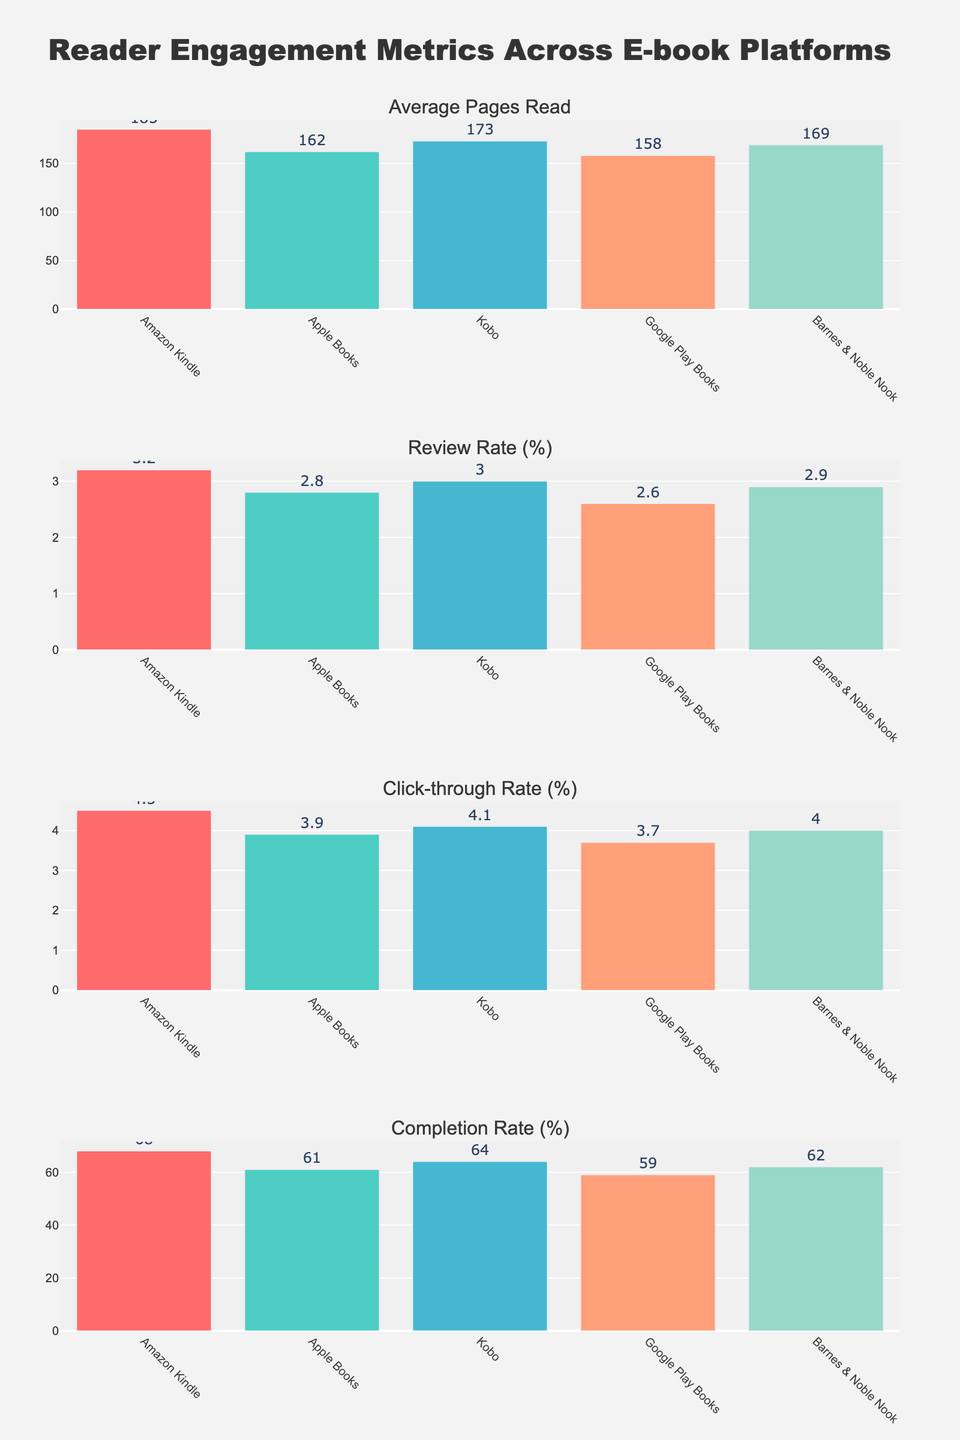Which platform has the highest average pages read? By examining the "Average Pages Read" subplot, we can identify the tallest bar, which corresponds to Amazon Kindle at 185 pages.
Answer: Amazon Kindle Which platform has the lowest click-through rate (%)? By looking at the "Click-through Rate (%)" subplot, we can see that Google Play Books has the shortest bar, which is 3.7%.
Answer: Google Play Books What is the total review rate (%) across all platforms? The total review rate is obtained by summing the review rates of all platforms: 3.2% (Amazon Kindle) + 2.8% (Apple Books) + 3.0% (Kobo) + 2.6% (Google Play Books) + 2.9% (Barnes & Noble Nook) = 14.5%.
Answer: 14.5% Which two platforms have similar completion rates (%)? By comparing the "Completion Rate (%)" subplot, we can see that Kobo and Barnes & Noble Nook have similar completion rates—64% and 62% respectively.
Answer: Kobo, Barnes & Noble Nook How much higher is the average pages read on Amazon Kindle compared to Google Play Books? The average pages read on Amazon Kindle is 185, and on Google Play Books, it is 158. The difference is 185 - 158 = 27 pages.
Answer: 27 pages Which platform shows the most balanced metrics across all four subplots? To determine the most balanced platform, we can look at the heights of the bars for each platform across all subplots. Kobo exhibits relatively consistent values: 173 (pages), 3.0 (review), 4.1 (click-through), and 64% (completion).
Answer: Kobo Which platform has the second highest click-through rate (%)? In the "Click-through Rate (%)" subplot, the second tallest bar corresponds to Amazon Kindle with a rate of 4.5%.
Answer: Amazon Kindle If you combine the average pages read for Apple Books and Barnes & Noble Nook, how many more pages is this compared to Kobo? Apple Books has 162 pages, Barnes & Noble Nook has 169 pages, making their combined total 162 + 169 = 331 pages. Kobo has 173 pages. The difference is 331 - 173 = 158 pages.
Answer: 158 pages 